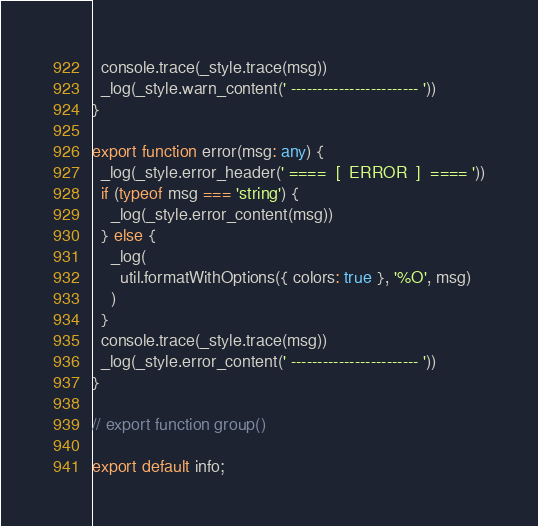Convert code to text. <code><loc_0><loc_0><loc_500><loc_500><_TypeScript_>  console.trace(_style.trace(msg))
  _log(_style.warn_content(' ------------------------ '))
}

export function error(msg: any) {
  _log(_style.error_header(' ====  [  ERROR  ]  ==== '))
  if (typeof msg === 'string') {
    _log(_style.error_content(msg))
  } else {
    _log(
      util.formatWithOptions({ colors: true }, '%O', msg)
    )
  }
  console.trace(_style.trace(msg))
  _log(_style.error_content(' ------------------------ '))
}

// export function group()

export default info;</code> 